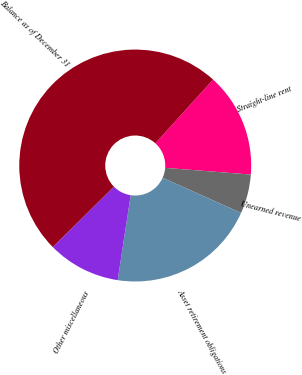Convert chart to OTSL. <chart><loc_0><loc_0><loc_500><loc_500><pie_chart><fcel>Straight-line rent<fcel>Unearned revenue<fcel>Asset retirement obligations<fcel>Other miscellaneous<fcel>Balance as of December 31<nl><fcel>14.53%<fcel>5.46%<fcel>20.72%<fcel>10.17%<fcel>49.12%<nl></chart> 